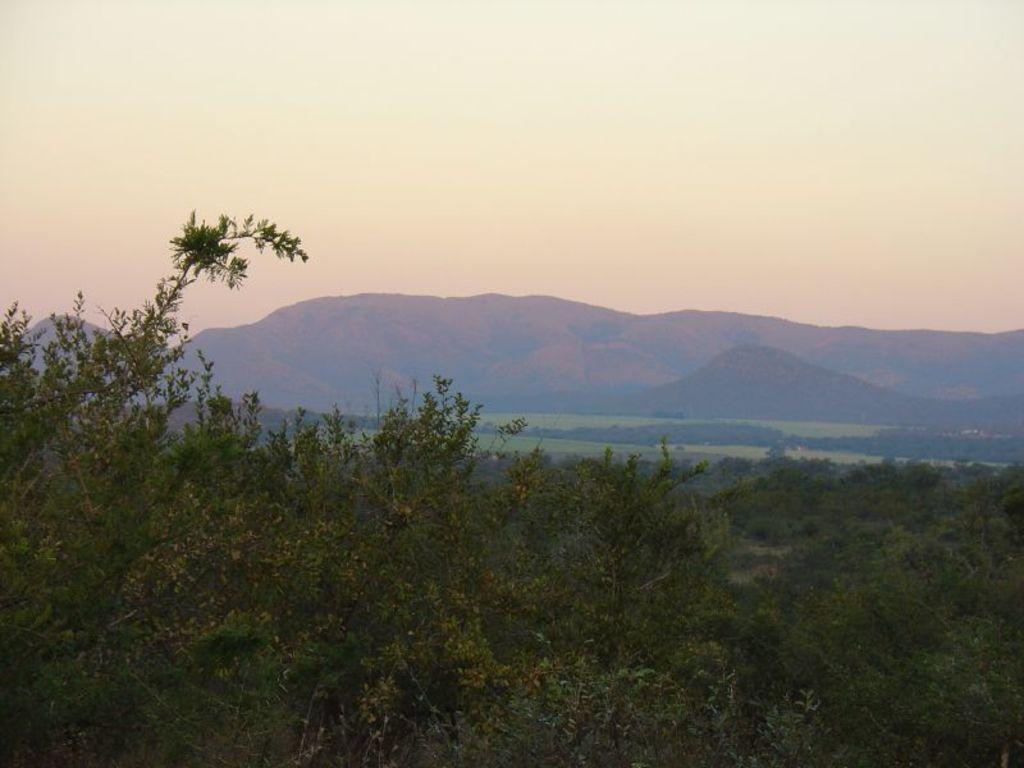How would you summarize this image in a sentence or two? In the foreground we can see trees. In the middle of the picture we can see hills, greenery. At the top there is sky. 